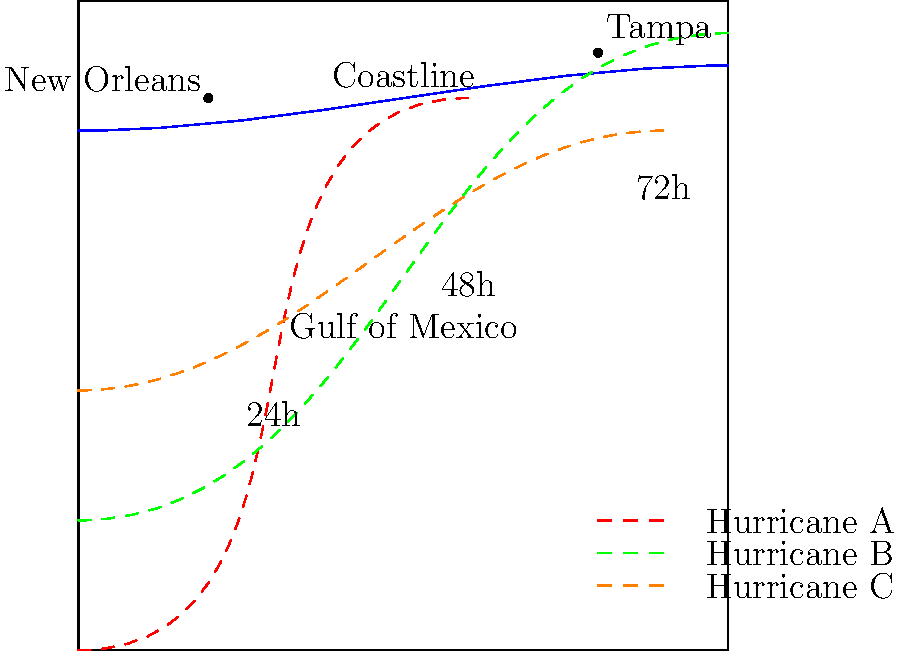Based on the hurricane tracking map, which storm poses the most immediate threat to New Orleans, and approximately how many hours until it potentially makes landfall? To answer this question, we need to analyze the paths of the three hurricanes (A, B, and C) in relation to New Orleans:

1. Identify New Orleans on the map: It's located on the coastline, marked with a dot in the western part of the map.

2. Examine each hurricane path:
   - Hurricane A (red dashed line): Closest to New Orleans, moving directly towards it.
   - Hurricane B (green dashed line): Moving north of New Orleans, likely to miss the city.
   - Hurricane C (orange dashed line): Moving south of New Orleans, also likely to miss the city.

3. Determine the most immediate threat: Hurricane A is clearly the most immediate threat to New Orleans as it's on a direct path to the city.

4. Estimate time to landfall for Hurricane A:
   - The map shows time markers at 24h, 48h, and 72h intervals.
   - Hurricane A's path reaches the coastline just before the 48h marker.

5. Conclude: Hurricane A is the most immediate threat, and it's estimated to make landfall in approximately 48 hours.
Answer: Hurricane A, approximately 48 hours 